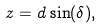<formula> <loc_0><loc_0><loc_500><loc_500>z = d \sin ( \delta ) ,</formula> 